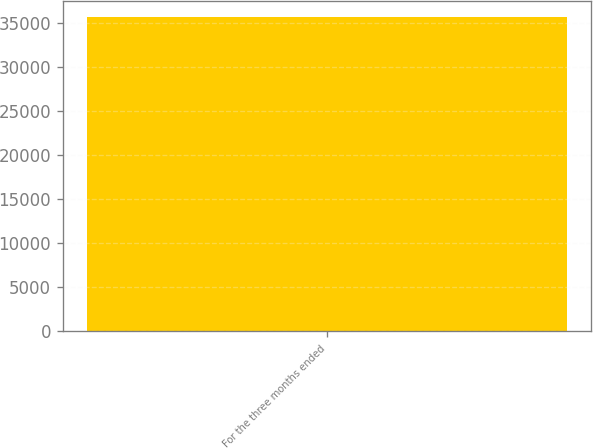<chart> <loc_0><loc_0><loc_500><loc_500><bar_chart><fcel>For the three months ended<nl><fcel>35615<nl></chart> 